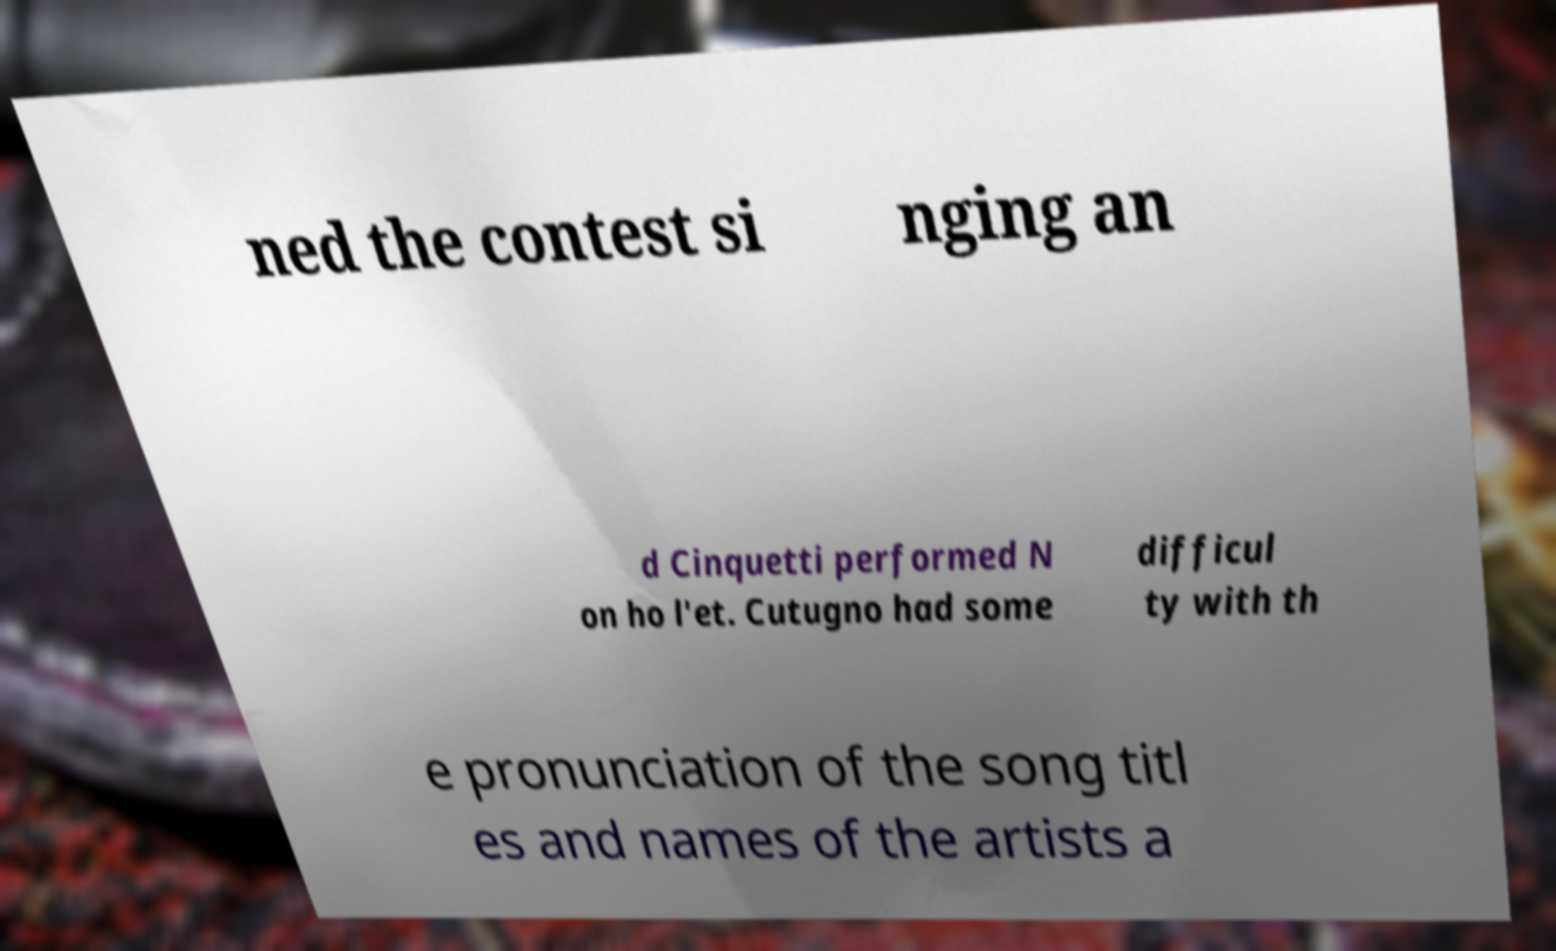Could you assist in decoding the text presented in this image and type it out clearly? ned the contest si nging an d Cinquetti performed N on ho l'et. Cutugno had some difficul ty with th e pronunciation of the song titl es and names of the artists a 